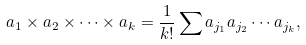Convert formula to latex. <formula><loc_0><loc_0><loc_500><loc_500>a _ { 1 } \times a _ { 2 } \times \cdots \times a _ { k } = \frac { 1 } { k ! } \sum a _ { j _ { 1 } } a _ { j _ { 2 } } \cdots a _ { j _ { k } } ,</formula> 